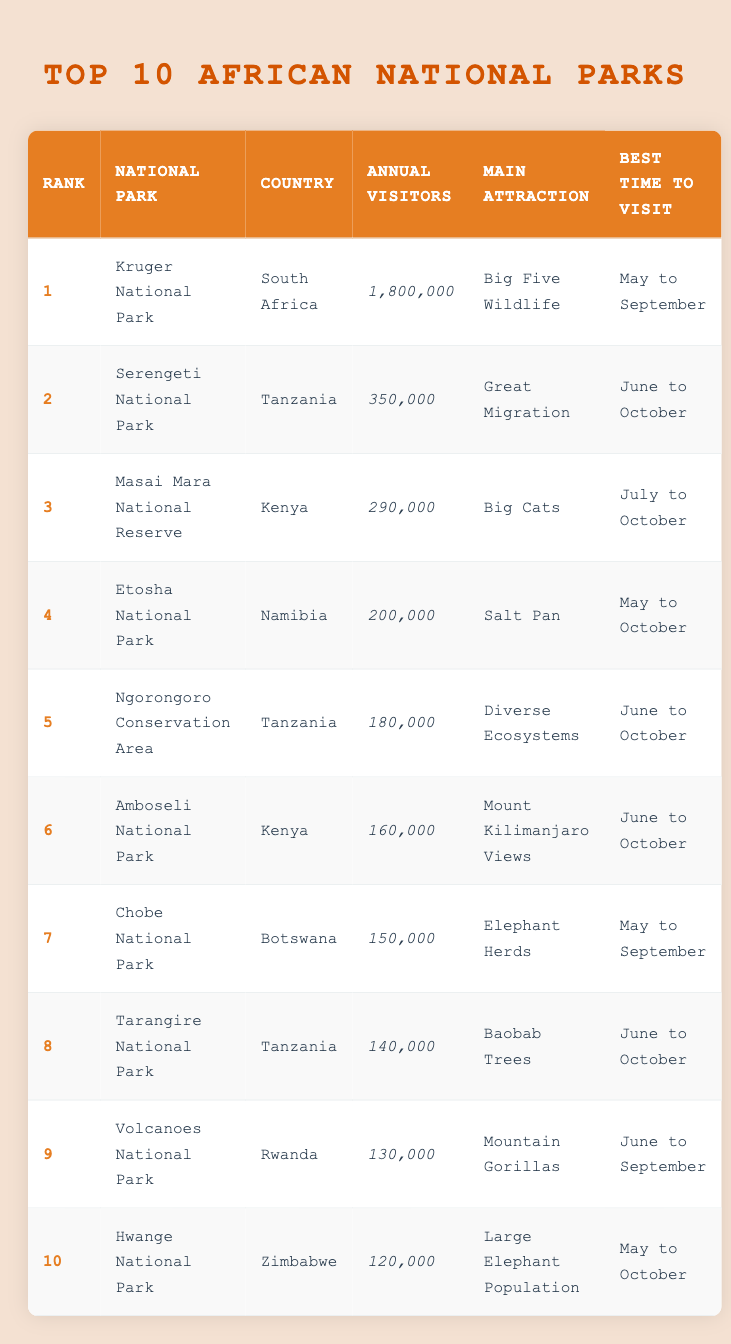What is the annual visitor count for Kruger National Park? The table lists Kruger National Park under the column "Annual Visitors," indicating it has 1,800,000 visitors.
Answer: 1,800,000 Which national park has the main attraction of mountain gorillas? The table indicates that the Volcanoes National Park is where mountain gorillas are the main attraction.
Answer: Volcanoes National Park How many more annual visitors does Kruger National Park have than Chobe National Park? Kruger National Park has 1,800,000 visitors while Chobe National Park has 150,000. The difference is 1,800,000 - 150,000 = 1,650,000.
Answer: 1,650,000 True or False: Amboseli National Park is in South Africa. The table shows that Amboseli National Park is in Kenya, so the statement is false.
Answer: False Which is the best time to visit Etosha National Park? According to the table, the best time to visit Etosha National Park is from May to October.
Answer: May to October What is the average number of annual visitors for the top three national parks? The top three parks have annual visitors of 1,800,000 (Kruger) + 350,000 (Serengeti) + 290,000 (Masai Mara) = 2,440,000. There are three parks, so the average is 2,440,000 / 3 = 813,333.33 (approximately 813,333).
Answer: 813,333 Which parks have an annual visitor count of less than 200,000? By reviewing the table, Etosha National Park (200,000), Ngorongoro Conservation Area (180,000), Amboseli National Park (160,000), Chobe National Park (150,000), Tarangire National Park (140,000), Volcanoes National Park (130,000), and Hwange National Park (120,000) are the ones with less than 200,000 annual visitors.
Answer: Ngorongoro Conservation Area, Amboseli National Park, Chobe National Park, Tarangire National Park, Volcanoes National Park, Hwange National Park What is the total number of annual visitors for the parks located in Tanzania? The table lists two parks in Tanzania: Serengeti National Park (350,000) and Ngorongoro Conservation Area (180,000). Summing these gives 350,000 + 180,000 = 530,000 annual visitors.
Answer: 530,000 How many parks are listed with the best time to visit being June to October? From the table, the parks with this timeframe are Serengeti National Park, Ngorongoro Conservation Area, Amboseli National Park, Tarangire National Park, and Volcanoes National Park. This totals to five parks.
Answer: 5 